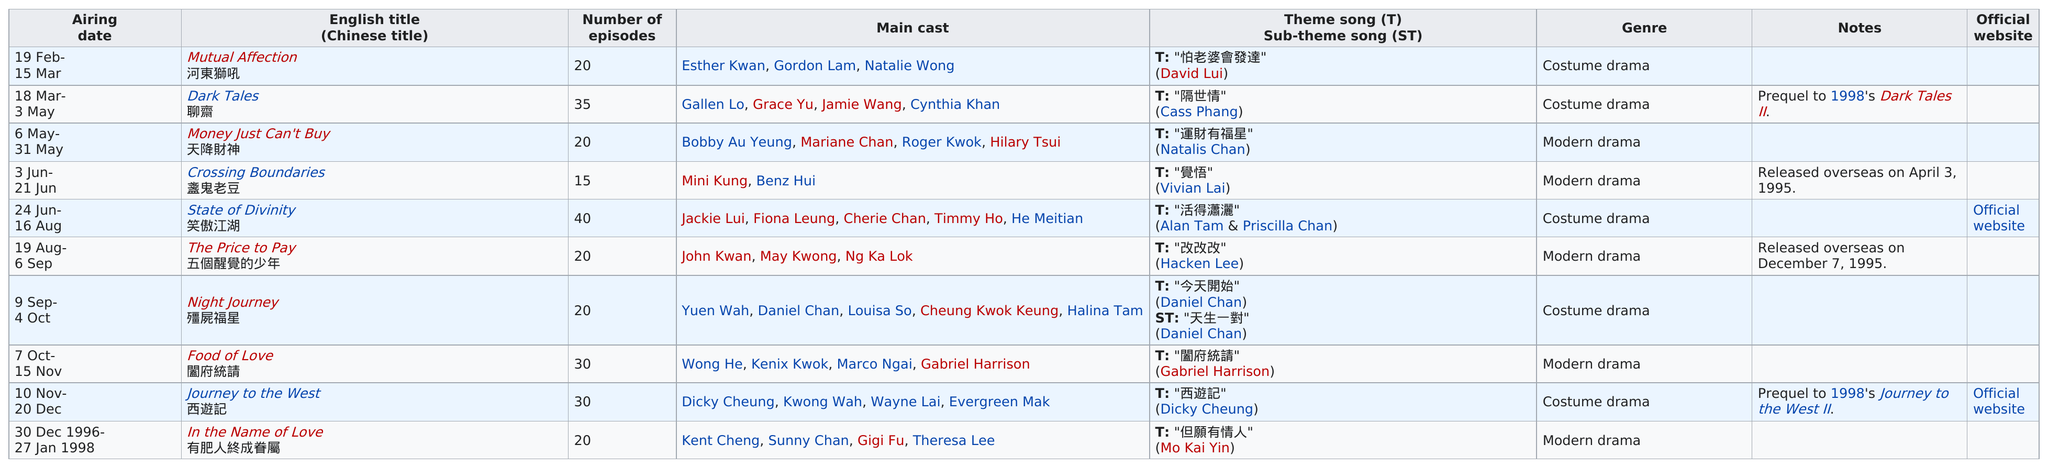Identify some key points in this picture. The longest running was 'In the Name of Love.' Out of the total number of shows, 5 were modern dramas. The Chinese drama 'State of Divinity' had the most number of episodes out of all Chinese dramas. Of the contemporary dramas included in the list, two are in a row. The co-star of 'Night Journey,' Daniel Chan, also performed the theme song for the show. 